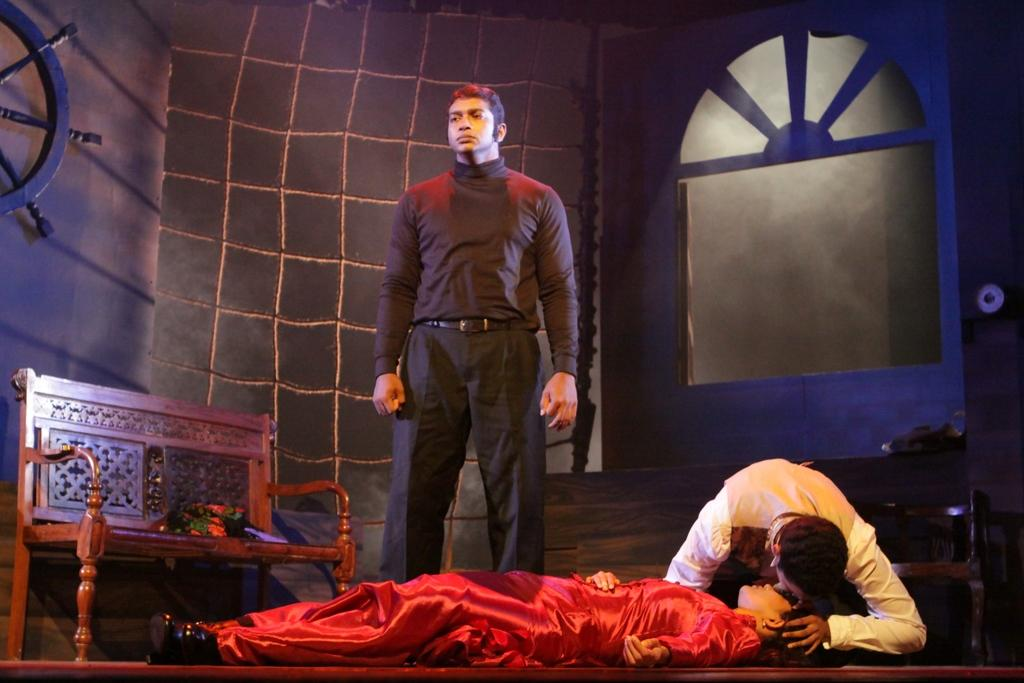How many people are present in the image? There are three persons in the image. What are the positions of the two people who are not lying on the floor? One person is kneeling, and the other person is standing. What type of furniture is present in the image? There is a bench in the image. What can be seen in the background of the image? There is a net and a window visible in the background. What type of organization is responsible for the net in the image? There is no information about an organization responsible for the net in the image. How many numbers are visible in the image? There are no numbers visible in the image. 